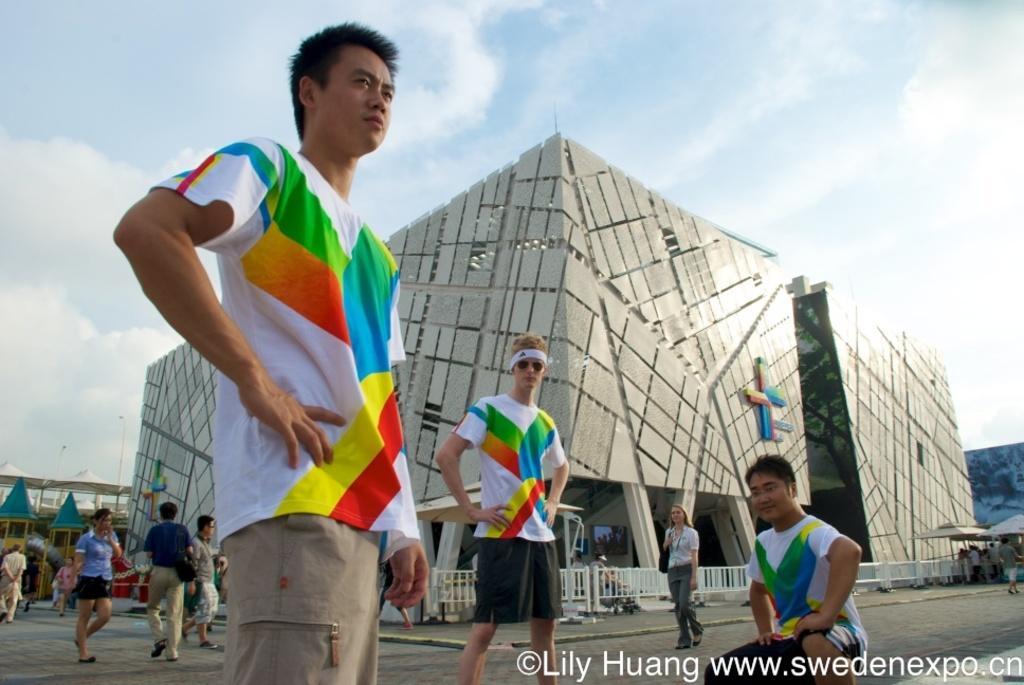Could you give a brief overview of what you see in this image? In this image we can see buildings, people, fence and in the background we can see the sky. 